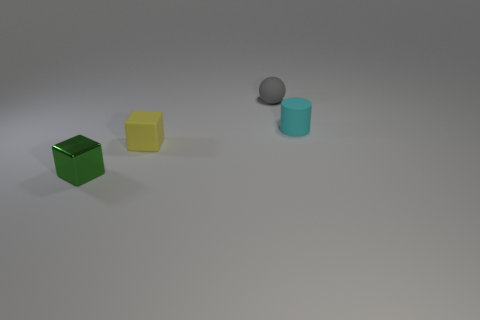Is the number of small gray matte spheres that are to the left of the tiny sphere less than the number of tiny cyan cylinders that are behind the green block?
Your answer should be compact. Yes. How many other objects are the same material as the tiny green object?
Offer a very short reply. 0. What material is the green cube that is the same size as the cyan rubber cylinder?
Your response must be concise. Metal. Are there fewer small green metallic cubes in front of the shiny cube than yellow things?
Provide a succinct answer. Yes. What is the shape of the tiny thing in front of the rubber object in front of the tiny rubber object on the right side of the gray matte ball?
Your answer should be compact. Cube. What size is the yellow matte thing to the left of the small gray ball?
Provide a short and direct response. Small. There is a gray matte object that is the same size as the green cube; what shape is it?
Provide a short and direct response. Sphere. What number of things are either tiny gray objects or tiny cubes that are right of the metal cube?
Offer a terse response. 2. What number of shiny blocks are right of the object that is behind the thing right of the gray ball?
Make the answer very short. 0. There is a ball that is made of the same material as the cyan thing; what is its color?
Offer a very short reply. Gray. 